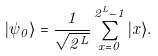Convert formula to latex. <formula><loc_0><loc_0><loc_500><loc_500>| \psi _ { 0 } \rangle = \frac { 1 } { \sqrt { 2 ^ { L } } } \sum _ { x = 0 } ^ { 2 ^ { L } - 1 } | x \rangle .</formula> 